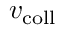<formula> <loc_0><loc_0><loc_500><loc_500>v _ { c o l l }</formula> 